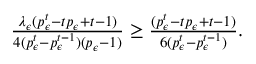Convert formula to latex. <formula><loc_0><loc_0><loc_500><loc_500>\begin{array} { r } { \frac { \lambda _ { \epsilon } ( p _ { \epsilon } ^ { t } - t p _ { \epsilon } + t - 1 ) } { 4 ( p _ { \epsilon } ^ { t } - p _ { \epsilon } ^ { t - 1 } ) ( p _ { \epsilon } - 1 ) } \geq \frac { ( p _ { \epsilon } ^ { t } - t p _ { \epsilon } + t - 1 ) } { 6 ( p _ { \epsilon } ^ { t } - p _ { \epsilon } ^ { t - 1 } ) } . } \end{array}</formula> 